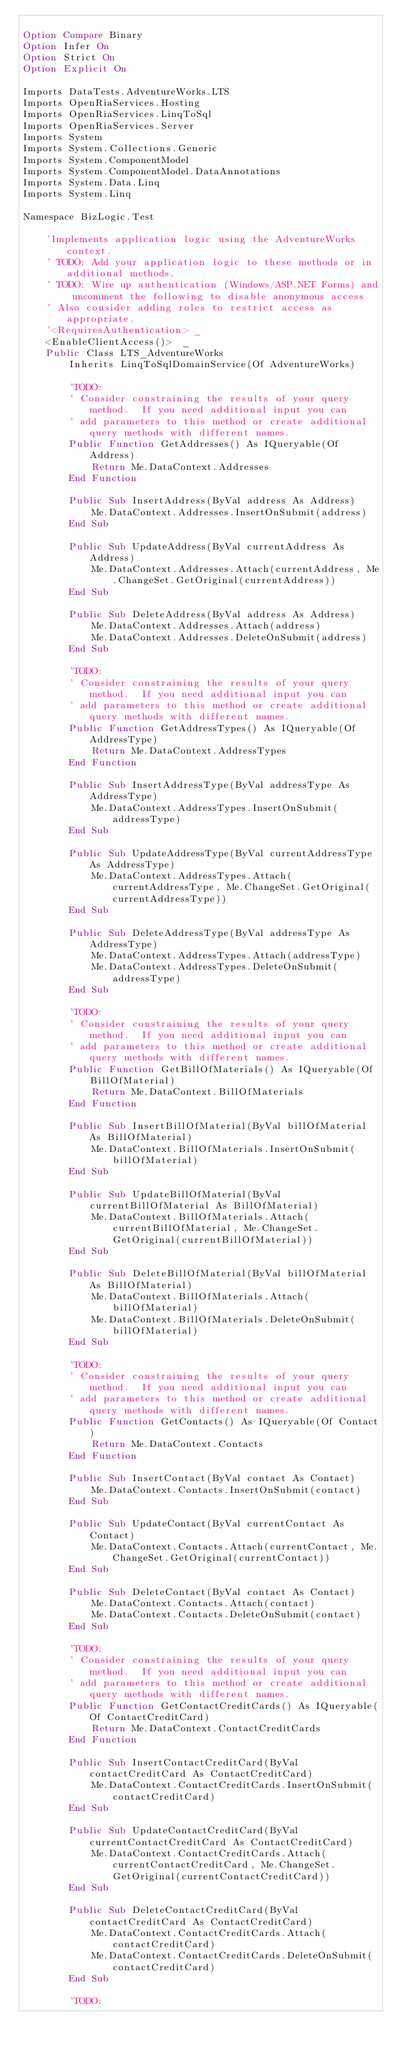Convert code to text. <code><loc_0><loc_0><loc_500><loc_500><_VisualBasic_>
Option Compare Binary
Option Infer On
Option Strict On
Option Explicit On

Imports DataTests.AdventureWorks.LTS
Imports OpenRiaServices.Hosting
Imports OpenRiaServices.LinqToSql
Imports OpenRiaServices.Server
Imports System
Imports System.Collections.Generic
Imports System.ComponentModel
Imports System.ComponentModel.DataAnnotations
Imports System.Data.Linq
Imports System.Linq

Namespace BizLogic.Test
    
    'Implements application logic using the AdventureWorks context.
    ' TODO: Add your application logic to these methods or in additional methods.
    ' TODO: Wire up authentication (Windows/ASP.NET Forms) and uncomment the following to disable anonymous access
    ' Also consider adding roles to restrict access as appropriate.
    '<RequiresAuthentication> _
    <EnableClientAccess()>  _
    Public Class LTS_AdventureWorks
        Inherits LinqToSqlDomainService(Of AdventureWorks)
        
        'TODO:
        ' Consider constraining the results of your query method.  If you need additional input you can
        ' add parameters to this method or create additional query methods with different names.
        Public Function GetAddresses() As IQueryable(Of Address)
            Return Me.DataContext.Addresses
        End Function
        
        Public Sub InsertAddress(ByVal address As Address)
            Me.DataContext.Addresses.InsertOnSubmit(address)
        End Sub
        
        Public Sub UpdateAddress(ByVal currentAddress As Address)
            Me.DataContext.Addresses.Attach(currentAddress, Me.ChangeSet.GetOriginal(currentAddress))
        End Sub
        
        Public Sub DeleteAddress(ByVal address As Address)
            Me.DataContext.Addresses.Attach(address)
            Me.DataContext.Addresses.DeleteOnSubmit(address)
        End Sub
        
        'TODO:
        ' Consider constraining the results of your query method.  If you need additional input you can
        ' add parameters to this method or create additional query methods with different names.
        Public Function GetAddressTypes() As IQueryable(Of AddressType)
            Return Me.DataContext.AddressTypes
        End Function
        
        Public Sub InsertAddressType(ByVal addressType As AddressType)
            Me.DataContext.AddressTypes.InsertOnSubmit(addressType)
        End Sub
        
        Public Sub UpdateAddressType(ByVal currentAddressType As AddressType)
            Me.DataContext.AddressTypes.Attach(currentAddressType, Me.ChangeSet.GetOriginal(currentAddressType))
        End Sub
        
        Public Sub DeleteAddressType(ByVal addressType As AddressType)
            Me.DataContext.AddressTypes.Attach(addressType)
            Me.DataContext.AddressTypes.DeleteOnSubmit(addressType)
        End Sub
        
        'TODO:
        ' Consider constraining the results of your query method.  If you need additional input you can
        ' add parameters to this method or create additional query methods with different names.
        Public Function GetBillOfMaterials() As IQueryable(Of BillOfMaterial)
            Return Me.DataContext.BillOfMaterials
        End Function
        
        Public Sub InsertBillOfMaterial(ByVal billOfMaterial As BillOfMaterial)
            Me.DataContext.BillOfMaterials.InsertOnSubmit(billOfMaterial)
        End Sub
        
        Public Sub UpdateBillOfMaterial(ByVal currentBillOfMaterial As BillOfMaterial)
            Me.DataContext.BillOfMaterials.Attach(currentBillOfMaterial, Me.ChangeSet.GetOriginal(currentBillOfMaterial))
        End Sub
        
        Public Sub DeleteBillOfMaterial(ByVal billOfMaterial As BillOfMaterial)
            Me.DataContext.BillOfMaterials.Attach(billOfMaterial)
            Me.DataContext.BillOfMaterials.DeleteOnSubmit(billOfMaterial)
        End Sub
        
        'TODO:
        ' Consider constraining the results of your query method.  If you need additional input you can
        ' add parameters to this method or create additional query methods with different names.
        Public Function GetContacts() As IQueryable(Of Contact)
            Return Me.DataContext.Contacts
        End Function
        
        Public Sub InsertContact(ByVal contact As Contact)
            Me.DataContext.Contacts.InsertOnSubmit(contact)
        End Sub
        
        Public Sub UpdateContact(ByVal currentContact As Contact)
            Me.DataContext.Contacts.Attach(currentContact, Me.ChangeSet.GetOriginal(currentContact))
        End Sub
        
        Public Sub DeleteContact(ByVal contact As Contact)
            Me.DataContext.Contacts.Attach(contact)
            Me.DataContext.Contacts.DeleteOnSubmit(contact)
        End Sub
        
        'TODO:
        ' Consider constraining the results of your query method.  If you need additional input you can
        ' add parameters to this method or create additional query methods with different names.
        Public Function GetContactCreditCards() As IQueryable(Of ContactCreditCard)
            Return Me.DataContext.ContactCreditCards
        End Function
        
        Public Sub InsertContactCreditCard(ByVal contactCreditCard As ContactCreditCard)
            Me.DataContext.ContactCreditCards.InsertOnSubmit(contactCreditCard)
        End Sub
        
        Public Sub UpdateContactCreditCard(ByVal currentContactCreditCard As ContactCreditCard)
            Me.DataContext.ContactCreditCards.Attach(currentContactCreditCard, Me.ChangeSet.GetOriginal(currentContactCreditCard))
        End Sub
        
        Public Sub DeleteContactCreditCard(ByVal contactCreditCard As ContactCreditCard)
            Me.DataContext.ContactCreditCards.Attach(contactCreditCard)
            Me.DataContext.ContactCreditCards.DeleteOnSubmit(contactCreditCard)
        End Sub
        
        'TODO:</code> 